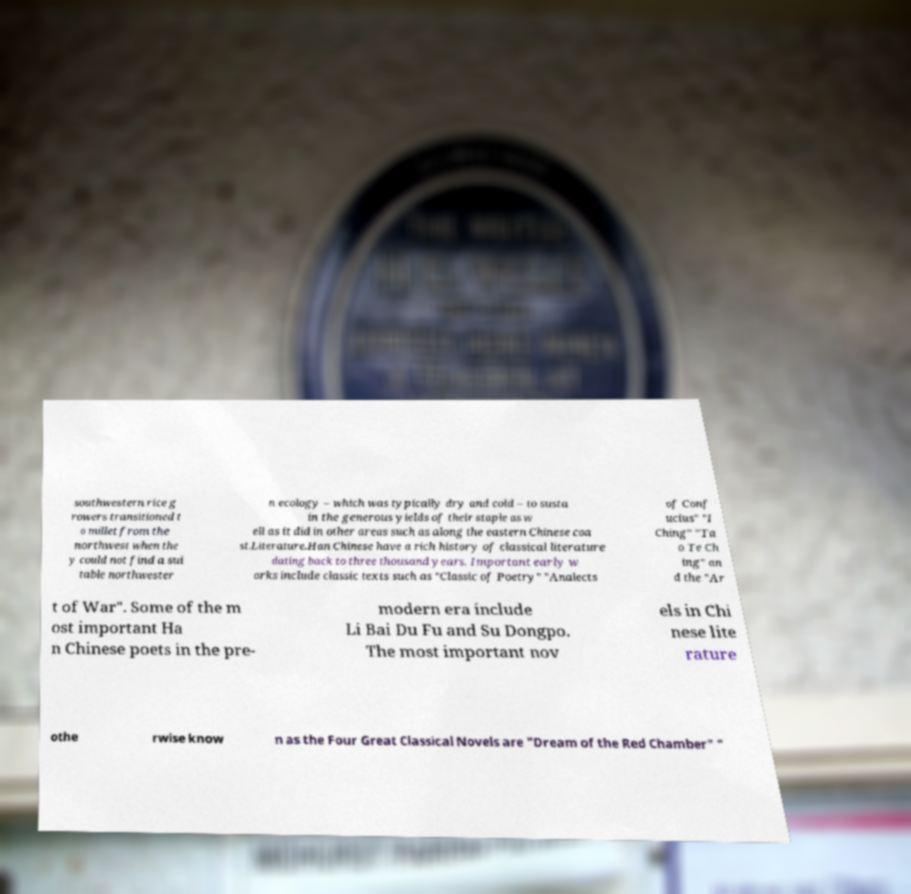What messages or text are displayed in this image? I need them in a readable, typed format. southwestern rice g rowers transitioned t o millet from the northwest when the y could not find a sui table northwester n ecology – which was typically dry and cold – to susta in the generous yields of their staple as w ell as it did in other areas such as along the eastern Chinese coa st.Literature.Han Chinese have a rich history of classical literature dating back to three thousand years. Important early w orks include classic texts such as "Classic of Poetry" "Analects of Conf ucius" "I Ching" "Ta o Te Ch ing" an d the "Ar t of War". Some of the m ost important Ha n Chinese poets in the pre- modern era include Li Bai Du Fu and Su Dongpo. The most important nov els in Chi nese lite rature othe rwise know n as the Four Great Classical Novels are "Dream of the Red Chamber" " 